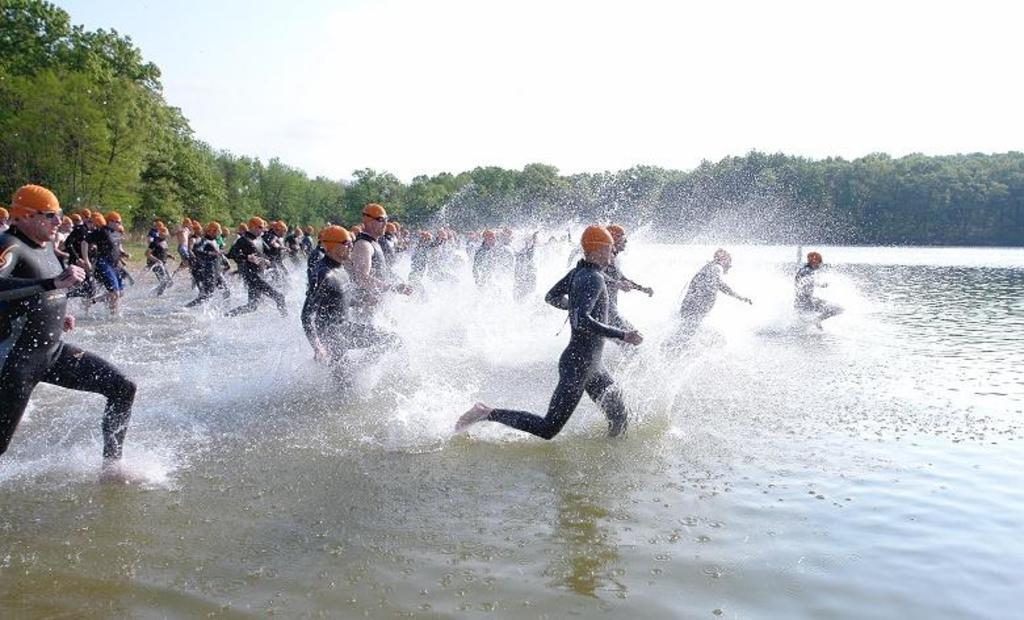What are the people in the image doing? The people in the image are running in the water. What is visible at the bottom of the image? There is water visible at the bottom of the image. What can be seen in the background of the image? There are trees in the background of the image. What is visible at the top of the image? The sky is visible at the top of the image. What type of toy can be seen in the hands of the giants in the image? There are no giants or toys present in the image. What sound do the bells make in the image? There are no bells present in the image. 